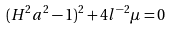Convert formula to latex. <formula><loc_0><loc_0><loc_500><loc_500>( H ^ { 2 } a ^ { 2 } - 1 ) ^ { 2 } + 4 l ^ { - 2 } \mu = 0</formula> 